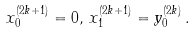<formula> <loc_0><loc_0><loc_500><loc_500>x _ { 0 } ^ { ( 2 k + 1 ) } = 0 , \, x _ { 1 } ^ { ( 2 k + 1 ) } = y _ { 0 } ^ { ( 2 k ) } \, .</formula> 